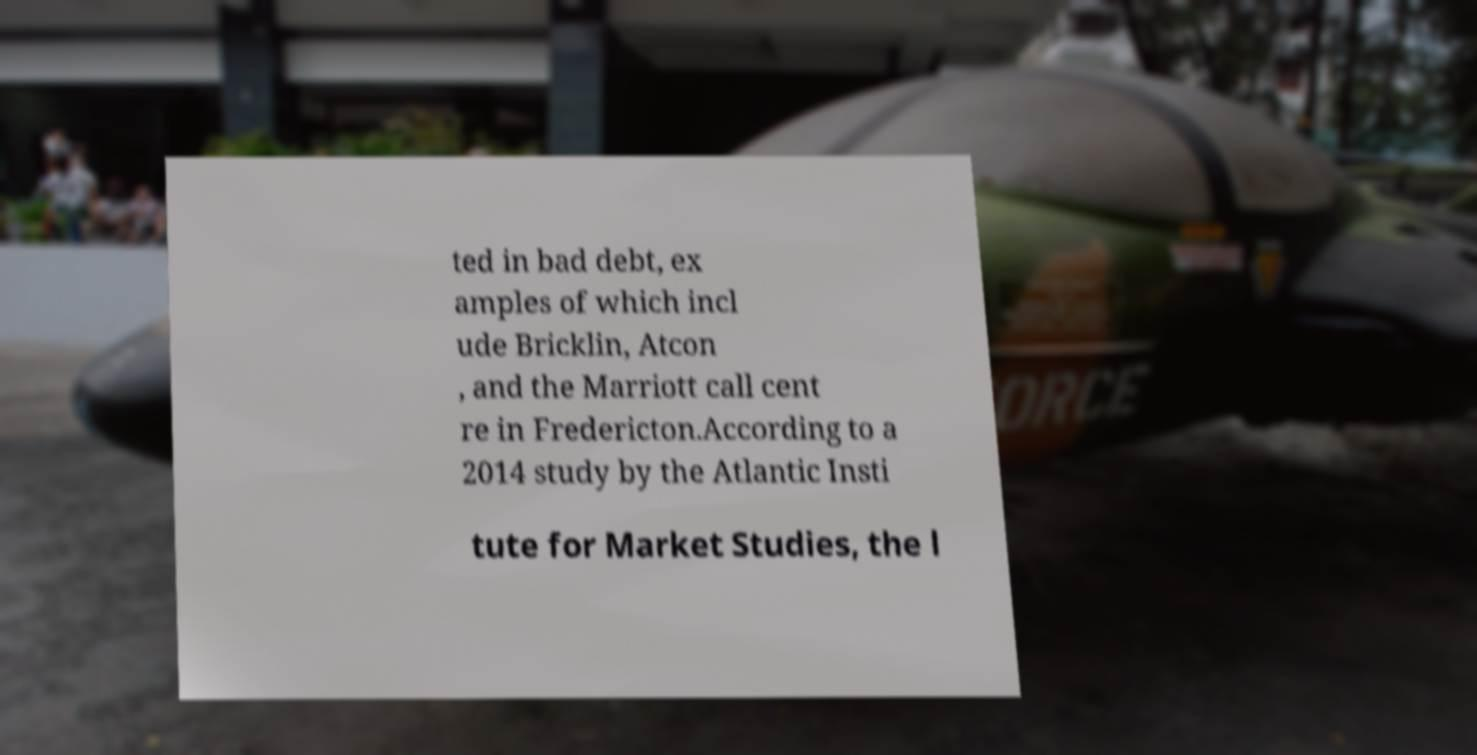Could you extract and type out the text from this image? ted in bad debt, ex amples of which incl ude Bricklin, Atcon , and the Marriott call cent re in Fredericton.According to a 2014 study by the Atlantic Insti tute for Market Studies, the l 